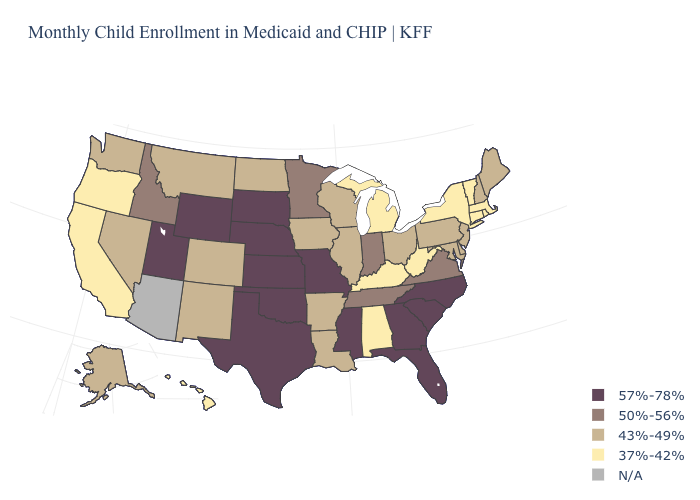Name the states that have a value in the range 43%-49%?
Answer briefly. Alaska, Arkansas, Colorado, Delaware, Illinois, Iowa, Louisiana, Maine, Maryland, Montana, Nevada, New Hampshire, New Jersey, New Mexico, North Dakota, Ohio, Pennsylvania, Washington, Wisconsin. Name the states that have a value in the range N/A?
Quick response, please. Arizona. What is the highest value in the Northeast ?
Give a very brief answer. 43%-49%. Does the first symbol in the legend represent the smallest category?
Short answer required. No. Name the states that have a value in the range 43%-49%?
Give a very brief answer. Alaska, Arkansas, Colorado, Delaware, Illinois, Iowa, Louisiana, Maine, Maryland, Montana, Nevada, New Hampshire, New Jersey, New Mexico, North Dakota, Ohio, Pennsylvania, Washington, Wisconsin. What is the lowest value in states that border Arkansas?
Quick response, please. 43%-49%. Which states have the highest value in the USA?
Answer briefly. Florida, Georgia, Kansas, Mississippi, Missouri, Nebraska, North Carolina, Oklahoma, South Carolina, South Dakota, Texas, Utah, Wyoming. Is the legend a continuous bar?
Short answer required. No. Among the states that border Arkansas , does Mississippi have the lowest value?
Keep it brief. No. What is the value of New Mexico?
Concise answer only. 43%-49%. What is the highest value in the South ?
Answer briefly. 57%-78%. Name the states that have a value in the range N/A?
Give a very brief answer. Arizona. Which states have the lowest value in the South?
Quick response, please. Alabama, Kentucky, West Virginia. 